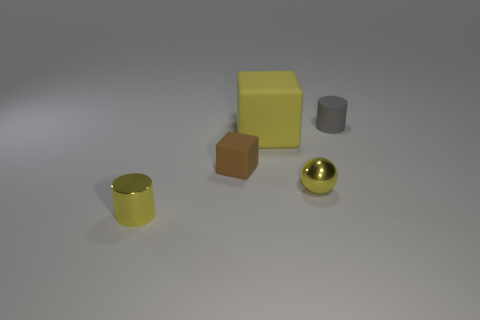Is there anything else that is the same material as the yellow sphere?
Your answer should be compact. Yes. There is another small object that is the same shape as the yellow rubber thing; what is its material?
Provide a succinct answer. Rubber. What is the size of the yellow object that is the same material as the sphere?
Your answer should be very brief. Small. How many tiny gray objects have the same shape as the yellow matte thing?
Make the answer very short. 0. Are there more tiny objects that are behind the tiny yellow metal cylinder than shiny objects on the right side of the yellow block?
Make the answer very short. Yes. There is a small shiny cylinder; is its color the same as the tiny sphere that is in front of the small matte cylinder?
Provide a succinct answer. Yes. There is a yellow sphere that is the same size as the gray cylinder; what is it made of?
Offer a very short reply. Metal. What number of objects are tiny gray rubber objects or tiny shiny things that are right of the big yellow cube?
Make the answer very short. 2. There is a yellow matte object; does it have the same size as the matte cube in front of the large yellow block?
Provide a short and direct response. No. What number of spheres are brown things or yellow rubber objects?
Your answer should be compact. 0. 